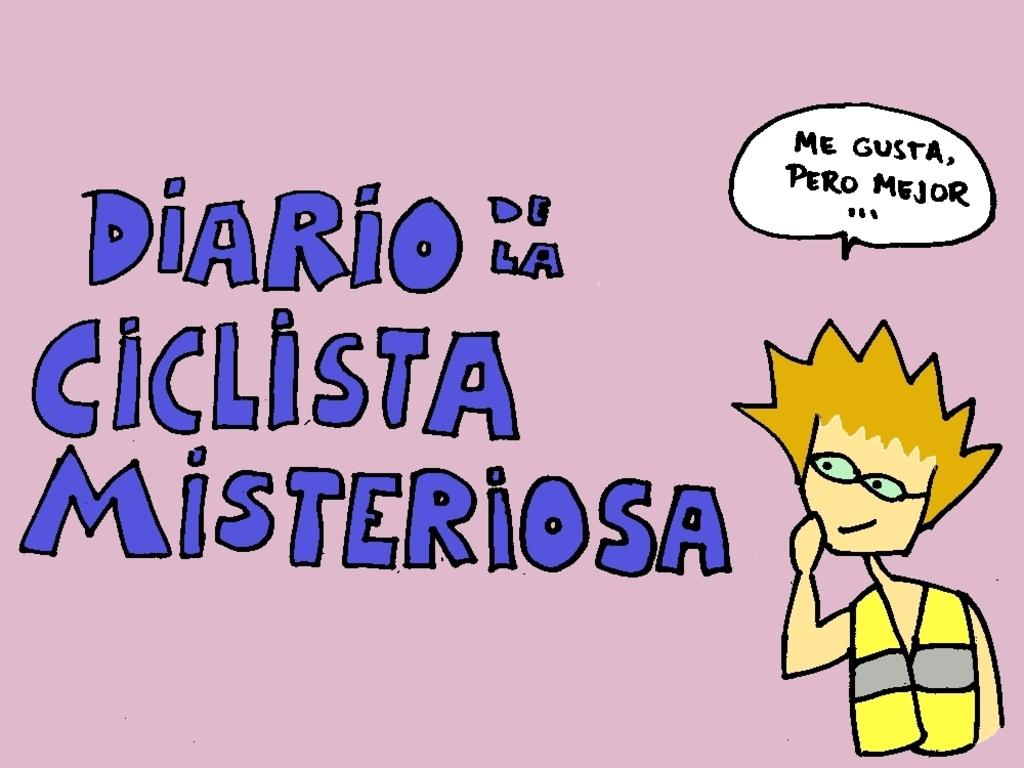What type of picture is in the image? There is a cartoon picture in the image. What else can be seen in the image besides the cartoon picture? There is text on a paper in the image. Can you tell me how many volleyballs are in the image? There are no volleyballs present in the image. What type of dinosaur can be seen playing with the net in the image? There is no dinosaur or net present in the image. 